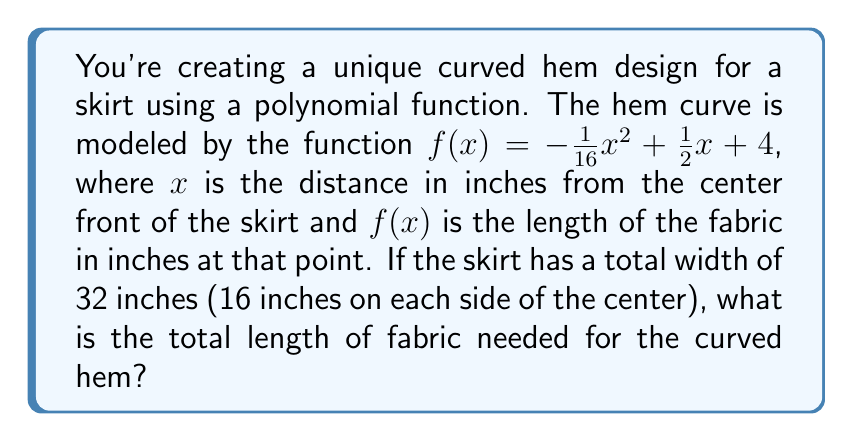Give your solution to this math problem. To solve this problem, we need to find the area under the curve of the polynomial function from $x = -16$ to $x = 16$. This can be done using definite integration.

1) The function given is $f(x) = -\frac{1}{16}x^2 + \frac{1}{2}x + 4$

2) To find the area, we need to integrate this function from -16 to 16:

   $$\int_{-16}^{16} (-\frac{1}{16}x^2 + \frac{1}{2}x + 4) dx$$

3) Let's integrate each term:
   
   $$[-\frac{1}{48}x^3 + \frac{1}{4}x^2 + 4x]_{-16}^{16}$$

4) Now, let's evaluate this at the upper and lower bounds:

   At x = 16:  $-\frac{1}{48}(16^3) + \frac{1}{4}(16^2) + 4(16) = -85.33 + 64 + 64 = 42.67$

   At x = -16: $-\frac{1}{48}(-16^3) + \frac{1}{4}(-16^2) + 4(-16) = 85.33 + 64 - 64 = 85.33$

5) Subtracting the lower bound from the upper bound:

   $42.67 - 85.33 = -42.66$

6) The negative sign here doesn't represent a negative length; it's just a result of the direction of integration. The absolute value gives us the actual length.

Therefore, the total length of fabric needed for the curved hem is approximately 42.66 inches.
Answer: 42.66 inches 